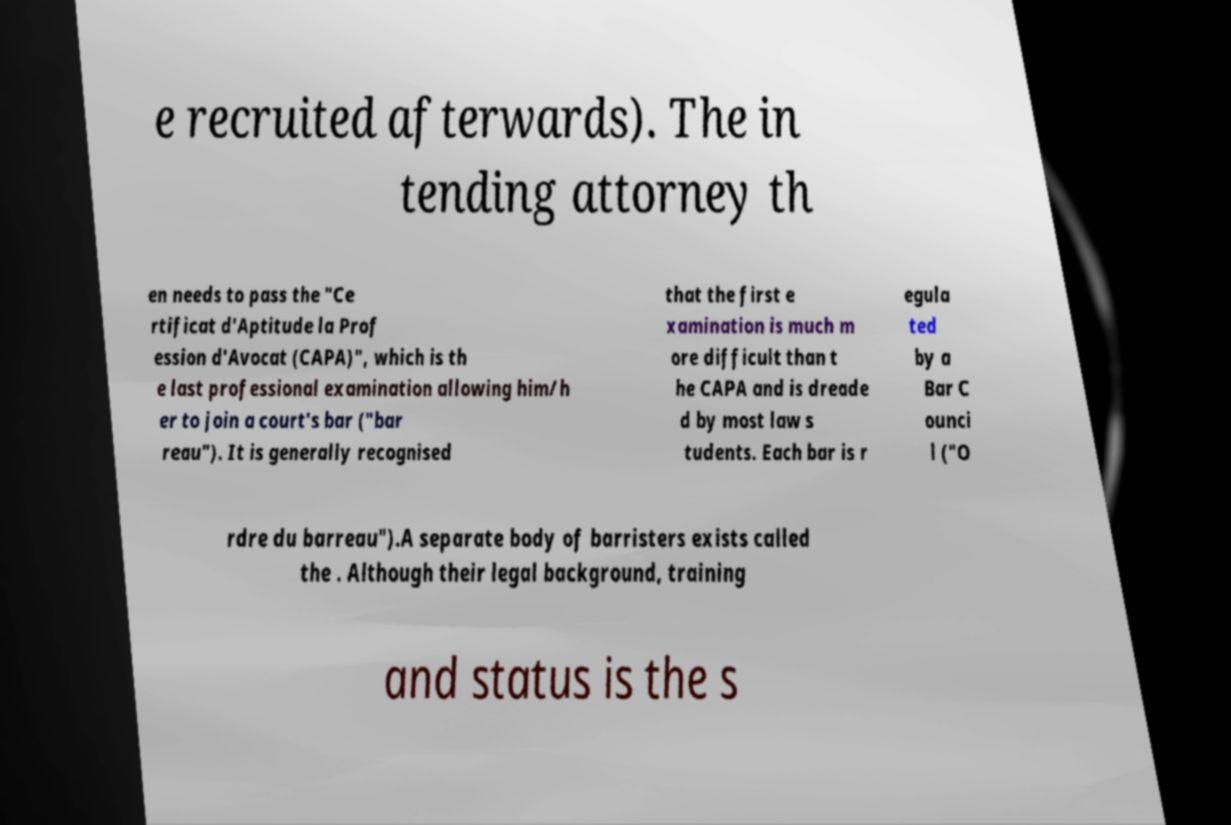Could you assist in decoding the text presented in this image and type it out clearly? e recruited afterwards). The in tending attorney th en needs to pass the "Ce rtificat d'Aptitude la Prof ession d'Avocat (CAPA)", which is th e last professional examination allowing him/h er to join a court's bar ("bar reau"). It is generally recognised that the first e xamination is much m ore difficult than t he CAPA and is dreade d by most law s tudents. Each bar is r egula ted by a Bar C ounci l ("O rdre du barreau").A separate body of barristers exists called the . Although their legal background, training and status is the s 